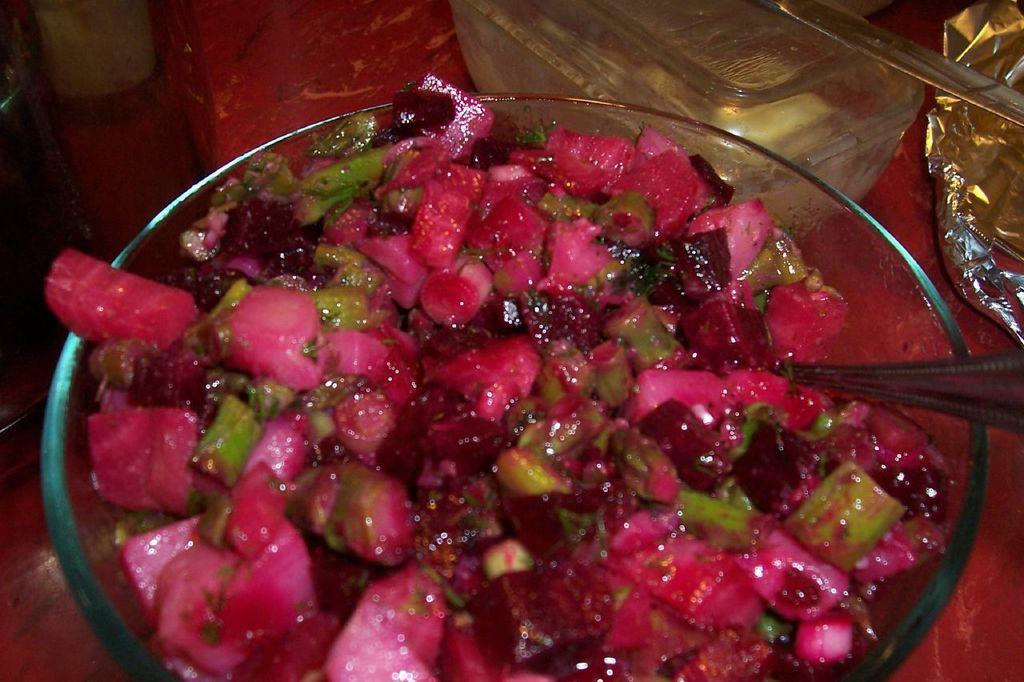What is in the bowl that is visible in the image? There is a food item in a bowl in the image. What utensil is in the bowl with the food item? There is a spoon in the bowl. What can be seen beside the bowl in the image? There are objects beside the bowl. On what surface is the bowl placed in the image? The bowl is on a glass table. What advice does the mom give about the food item in the image? There is no mom present in the image, so it is not possible to answer that question. 